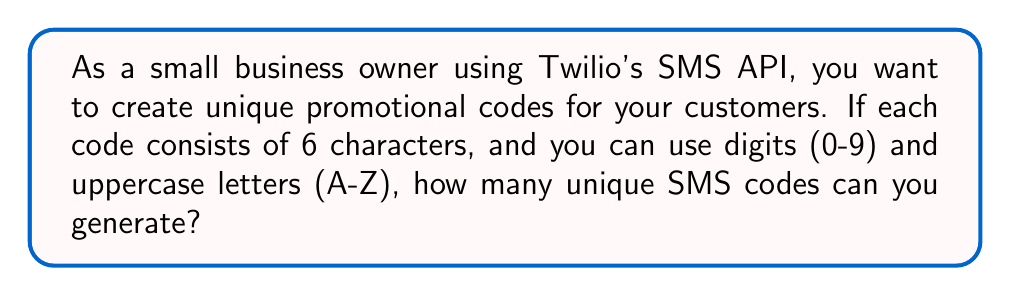Can you solve this math problem? To solve this problem, we need to use the concept of permutations with repetition. Here's a step-by-step explanation:

1. First, let's identify the number of possible characters we can use:
   - 10 digits (0-9)
   - 26 uppercase letters (A-Z)
   Total: 10 + 26 = 36 possible characters

2. Each position in the 6-character code can be filled by any of these 36 characters.

3. For each position, we have 36 choices, and we need to fill 6 positions.

4. The formula for permutations with repetition is:
   $$ n^r $$
   where $n$ is the number of possible characters and $r$ is the length of the code.

5. In this case:
   $$ n = 36 \text{ (possible characters)} $$
   $$ r = 6 \text{ (length of the code)} $$

6. Plugging these values into the formula:
   $$ 36^6 = 2,176,782,336 $$

Therefore, the number of unique SMS codes that can be generated is 2,176,782,336.
Answer: $2,176,782,336$ unique SMS codes 